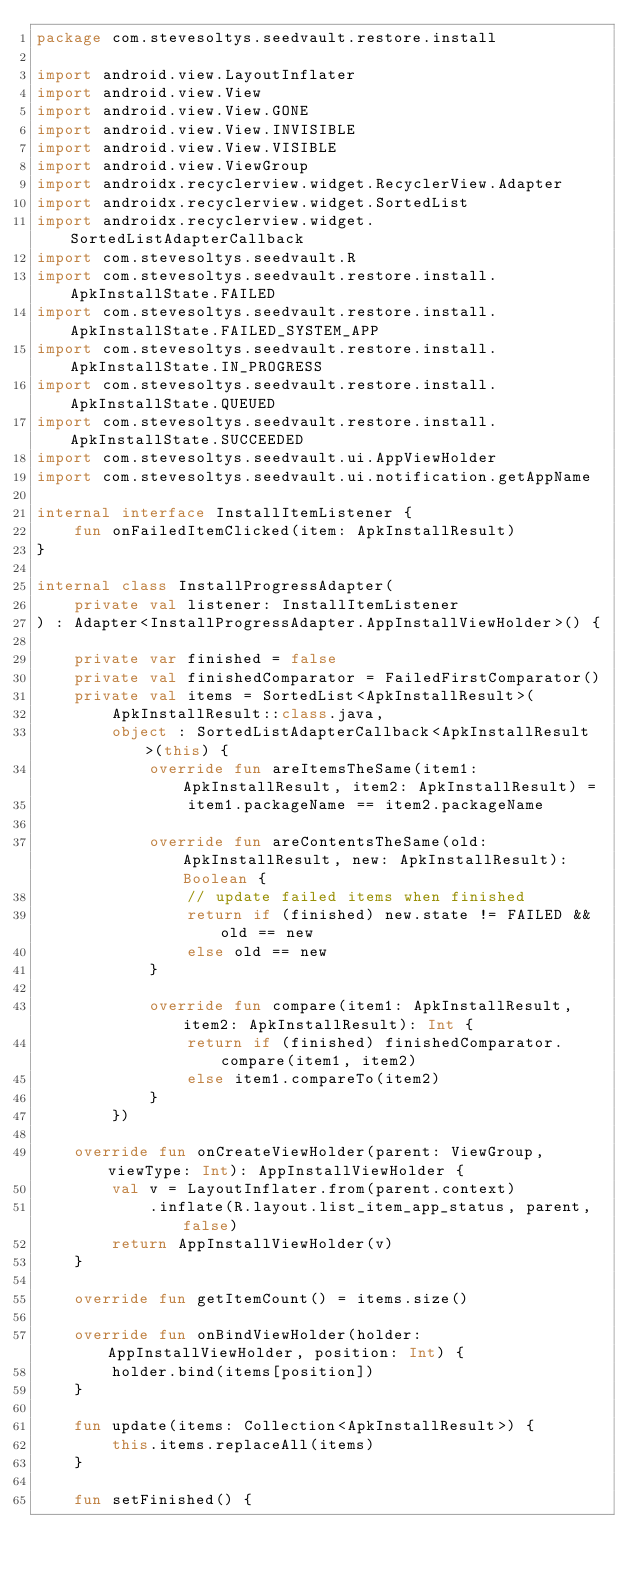<code> <loc_0><loc_0><loc_500><loc_500><_Kotlin_>package com.stevesoltys.seedvault.restore.install

import android.view.LayoutInflater
import android.view.View
import android.view.View.GONE
import android.view.View.INVISIBLE
import android.view.View.VISIBLE
import android.view.ViewGroup
import androidx.recyclerview.widget.RecyclerView.Adapter
import androidx.recyclerview.widget.SortedList
import androidx.recyclerview.widget.SortedListAdapterCallback
import com.stevesoltys.seedvault.R
import com.stevesoltys.seedvault.restore.install.ApkInstallState.FAILED
import com.stevesoltys.seedvault.restore.install.ApkInstallState.FAILED_SYSTEM_APP
import com.stevesoltys.seedvault.restore.install.ApkInstallState.IN_PROGRESS
import com.stevesoltys.seedvault.restore.install.ApkInstallState.QUEUED
import com.stevesoltys.seedvault.restore.install.ApkInstallState.SUCCEEDED
import com.stevesoltys.seedvault.ui.AppViewHolder
import com.stevesoltys.seedvault.ui.notification.getAppName

internal interface InstallItemListener {
    fun onFailedItemClicked(item: ApkInstallResult)
}

internal class InstallProgressAdapter(
    private val listener: InstallItemListener
) : Adapter<InstallProgressAdapter.AppInstallViewHolder>() {

    private var finished = false
    private val finishedComparator = FailedFirstComparator()
    private val items = SortedList<ApkInstallResult>(
        ApkInstallResult::class.java,
        object : SortedListAdapterCallback<ApkInstallResult>(this) {
            override fun areItemsTheSame(item1: ApkInstallResult, item2: ApkInstallResult) =
                item1.packageName == item2.packageName

            override fun areContentsTheSame(old: ApkInstallResult, new: ApkInstallResult): Boolean {
                // update failed items when finished
                return if (finished) new.state != FAILED && old == new
                else old == new
            }

            override fun compare(item1: ApkInstallResult, item2: ApkInstallResult): Int {
                return if (finished) finishedComparator.compare(item1, item2)
                else item1.compareTo(item2)
            }
        })

    override fun onCreateViewHolder(parent: ViewGroup, viewType: Int): AppInstallViewHolder {
        val v = LayoutInflater.from(parent.context)
            .inflate(R.layout.list_item_app_status, parent, false)
        return AppInstallViewHolder(v)
    }

    override fun getItemCount() = items.size()

    override fun onBindViewHolder(holder: AppInstallViewHolder, position: Int) {
        holder.bind(items[position])
    }

    fun update(items: Collection<ApkInstallResult>) {
        this.items.replaceAll(items)
    }

    fun setFinished() {</code> 